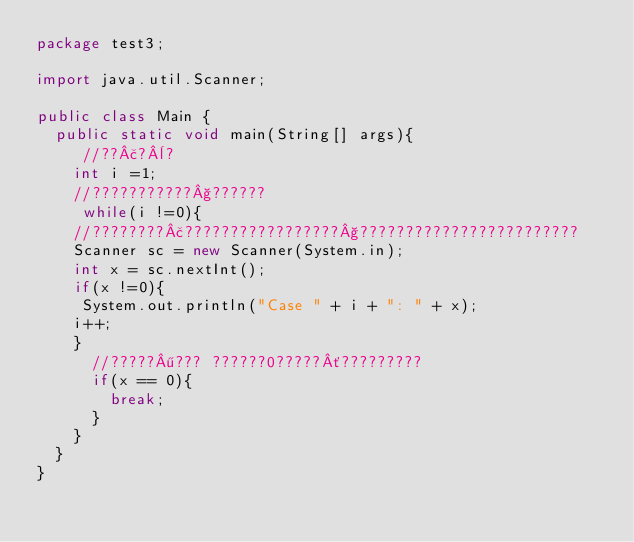<code> <loc_0><loc_0><loc_500><loc_500><_Java_>package test3;

import java.util.Scanner;

public class Main {
	public static void main(String[] args){
		 //??£?¨?
		int i =1;
		//???????????§??????
		 while(i !=0){
		//????????£?????????????????§????????????????????????
		Scanner sc = new Scanner(System.in);
		int x = sc.nextInt();
		if(x !=0){
		 System.out.println("Case " + i + ": " + x);
		i++;
		}
			//?????¶??? ??????0?????´?????????
			if(x == 0){
				break;
			}
		}
	}
}</code> 